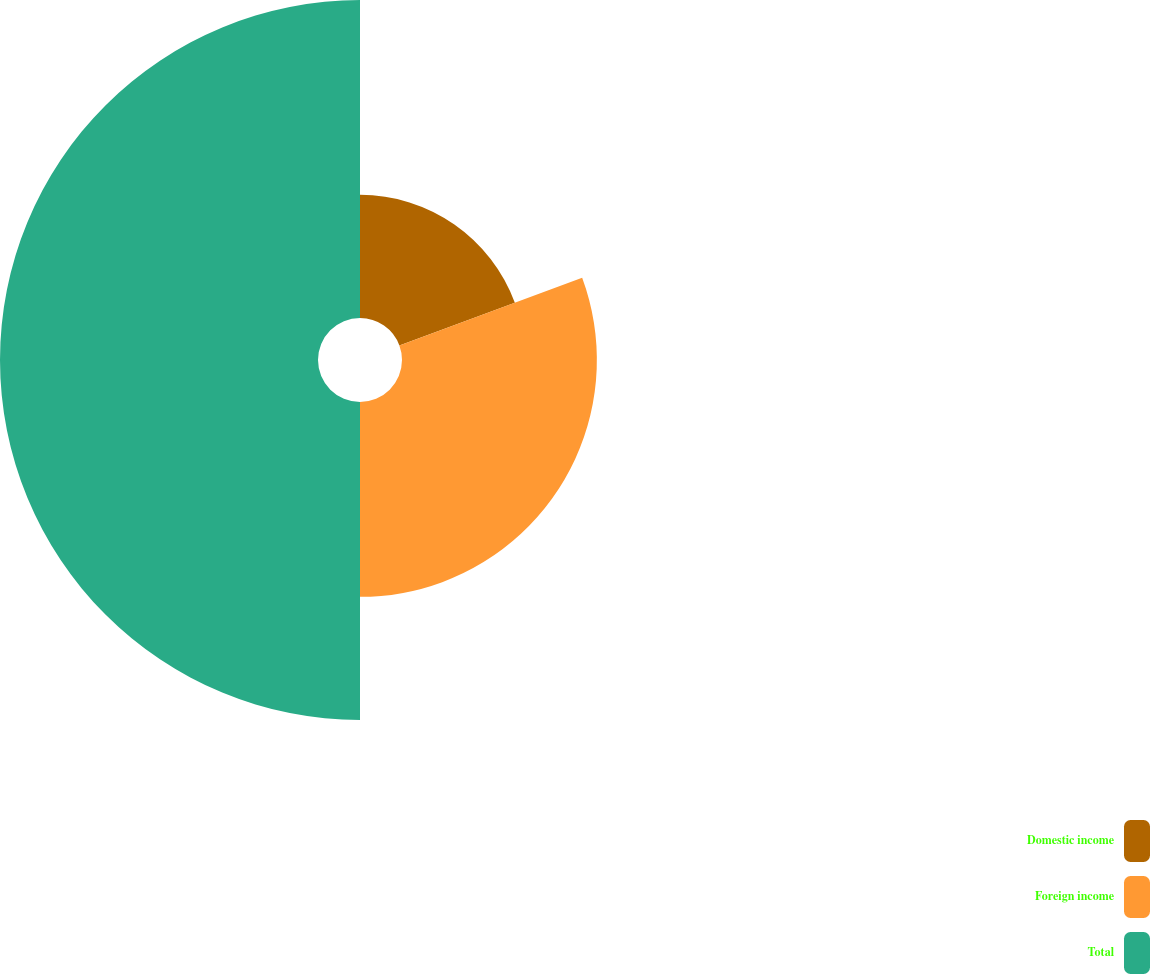Convert chart. <chart><loc_0><loc_0><loc_500><loc_500><pie_chart><fcel>Domestic income<fcel>Foreign income<fcel>Total<nl><fcel>19.36%<fcel>30.64%<fcel>50.0%<nl></chart> 